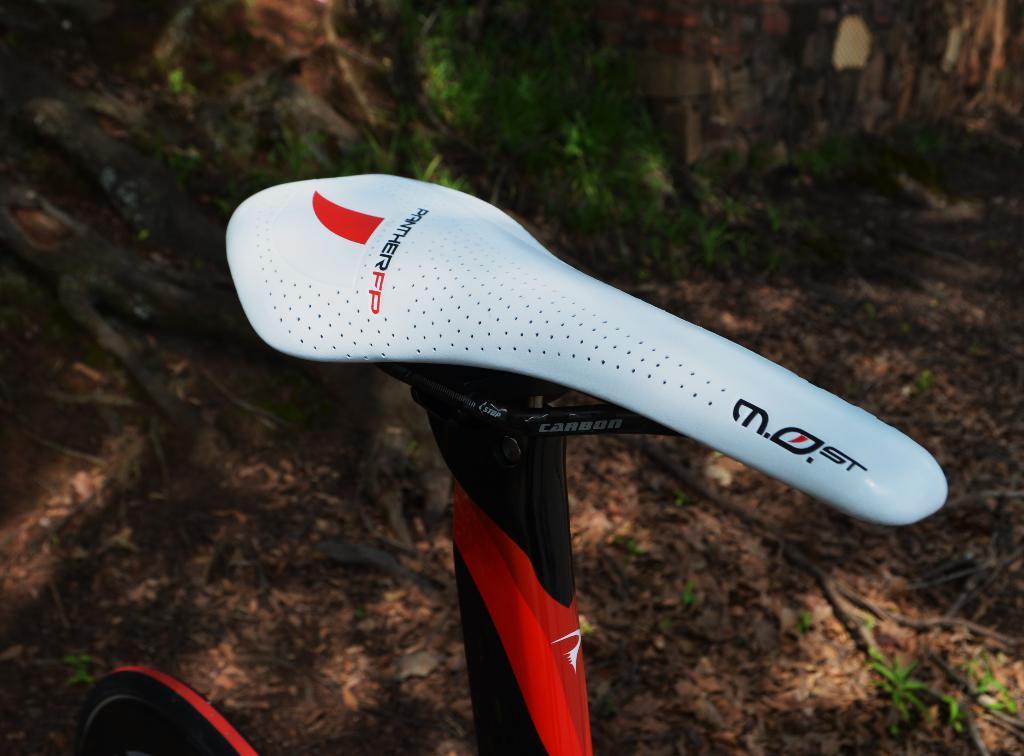In one or two sentences, can you explain what this image depicts? In this image in the front there is an object which is black, red and white in colour. In the background there are leaves and there is a wall and there are dry leaves on the ground. 